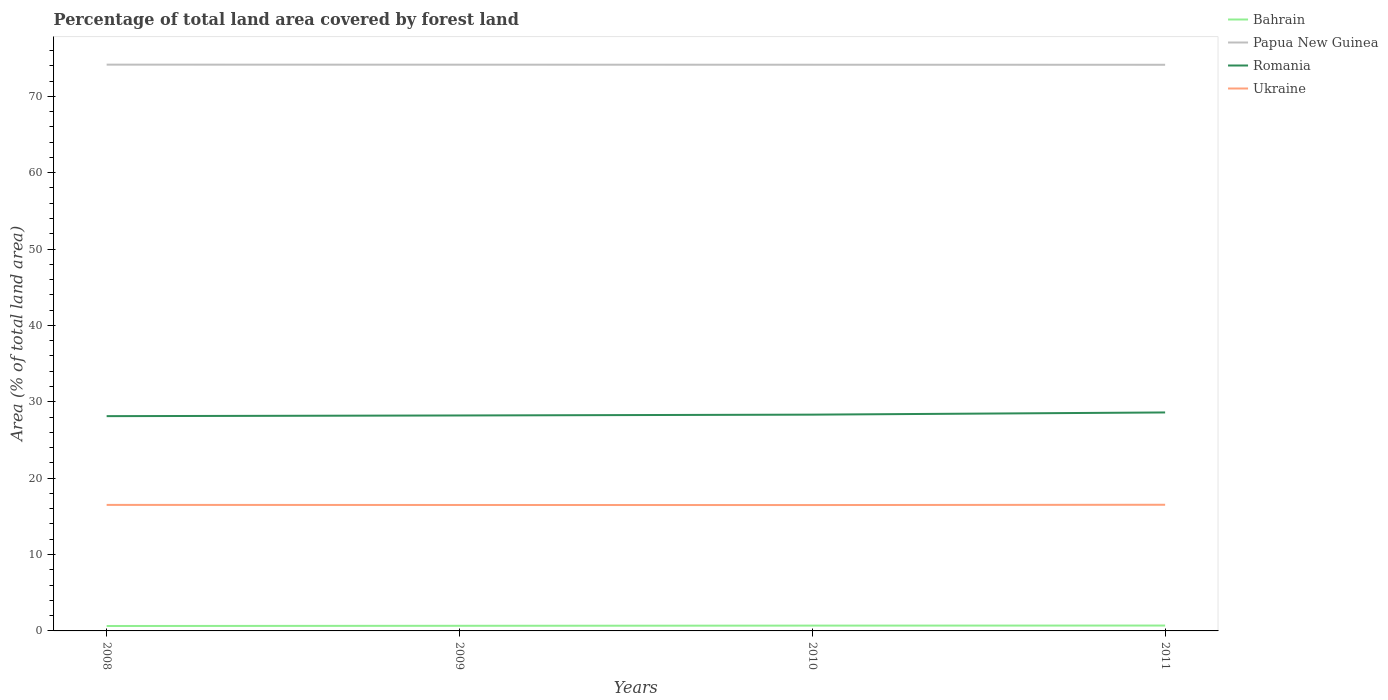Across all years, what is the maximum percentage of forest land in Papua New Guinea?
Provide a succinct answer. 74.13. In which year was the percentage of forest land in Romania maximum?
Offer a terse response. 2008. What is the total percentage of forest land in Papua New Guinea in the graph?
Provide a short and direct response. 0.01. What is the difference between the highest and the second highest percentage of forest land in Ukraine?
Offer a very short reply. 0.04. How many years are there in the graph?
Your answer should be compact. 4. What is the difference between two consecutive major ticks on the Y-axis?
Your response must be concise. 10. Are the values on the major ticks of Y-axis written in scientific E-notation?
Your answer should be compact. No. Does the graph contain any zero values?
Give a very brief answer. No. Does the graph contain grids?
Ensure brevity in your answer.  No. How many legend labels are there?
Offer a terse response. 4. What is the title of the graph?
Offer a terse response. Percentage of total land area covered by forest land. Does "Uzbekistan" appear as one of the legend labels in the graph?
Provide a succinct answer. No. What is the label or title of the Y-axis?
Your answer should be compact. Area (% of total land area). What is the Area (% of total land area) of Bahrain in 2008?
Your response must be concise. 0.64. What is the Area (% of total land area) of Papua New Guinea in 2008?
Your answer should be compact. 74.15. What is the Area (% of total land area) of Romania in 2008?
Your answer should be compact. 28.12. What is the Area (% of total land area) of Ukraine in 2008?
Your answer should be very brief. 16.5. What is the Area (% of total land area) of Bahrain in 2009?
Ensure brevity in your answer.  0.67. What is the Area (% of total land area) of Papua New Guinea in 2009?
Give a very brief answer. 74.14. What is the Area (% of total land area) of Romania in 2009?
Provide a short and direct response. 28.21. What is the Area (% of total land area) of Ukraine in 2009?
Your answer should be very brief. 16.49. What is the Area (% of total land area) of Bahrain in 2010?
Make the answer very short. 0.7. What is the Area (% of total land area) in Papua New Guinea in 2010?
Ensure brevity in your answer.  74.14. What is the Area (% of total land area) in Romania in 2010?
Offer a very short reply. 28.32. What is the Area (% of total land area) of Ukraine in 2010?
Provide a short and direct response. 16.48. What is the Area (% of total land area) of Bahrain in 2011?
Make the answer very short. 0.7. What is the Area (% of total land area) in Papua New Guinea in 2011?
Make the answer very short. 74.13. What is the Area (% of total land area) in Romania in 2011?
Provide a short and direct response. 28.61. What is the Area (% of total land area) of Ukraine in 2011?
Provide a succinct answer. 16.52. Across all years, what is the maximum Area (% of total land area) of Bahrain?
Offer a very short reply. 0.7. Across all years, what is the maximum Area (% of total land area) in Papua New Guinea?
Give a very brief answer. 74.15. Across all years, what is the maximum Area (% of total land area) in Romania?
Your response must be concise. 28.61. Across all years, what is the maximum Area (% of total land area) in Ukraine?
Keep it short and to the point. 16.52. Across all years, what is the minimum Area (% of total land area) of Bahrain?
Provide a short and direct response. 0.64. Across all years, what is the minimum Area (% of total land area) of Papua New Guinea?
Provide a succinct answer. 74.13. Across all years, what is the minimum Area (% of total land area) of Romania?
Keep it short and to the point. 28.12. Across all years, what is the minimum Area (% of total land area) of Ukraine?
Offer a terse response. 16.48. What is the total Area (% of total land area) in Bahrain in the graph?
Your answer should be very brief. 2.72. What is the total Area (% of total land area) of Papua New Guinea in the graph?
Offer a very short reply. 296.55. What is the total Area (% of total land area) in Romania in the graph?
Your response must be concise. 113.26. What is the total Area (% of total land area) of Ukraine in the graph?
Your answer should be compact. 65.99. What is the difference between the Area (% of total land area) in Bahrain in 2008 and that in 2009?
Offer a very short reply. -0.03. What is the difference between the Area (% of total land area) in Papua New Guinea in 2008 and that in 2009?
Offer a very short reply. 0.01. What is the difference between the Area (% of total land area) in Romania in 2008 and that in 2009?
Make the answer very short. -0.09. What is the difference between the Area (% of total land area) of Ukraine in 2008 and that in 2009?
Give a very brief answer. 0.01. What is the difference between the Area (% of total land area) in Bahrain in 2008 and that in 2010?
Your response must be concise. -0.05. What is the difference between the Area (% of total land area) in Papua New Guinea in 2008 and that in 2010?
Provide a short and direct response. 0.01. What is the difference between the Area (% of total land area) of Romania in 2008 and that in 2010?
Make the answer very short. -0.2. What is the difference between the Area (% of total land area) in Ukraine in 2008 and that in 2010?
Provide a short and direct response. 0.02. What is the difference between the Area (% of total land area) in Bahrain in 2008 and that in 2011?
Offer a terse response. -0.06. What is the difference between the Area (% of total land area) in Papua New Guinea in 2008 and that in 2011?
Ensure brevity in your answer.  0.02. What is the difference between the Area (% of total land area) in Romania in 2008 and that in 2011?
Offer a terse response. -0.48. What is the difference between the Area (% of total land area) of Ukraine in 2008 and that in 2011?
Give a very brief answer. -0.02. What is the difference between the Area (% of total land area) in Bahrain in 2009 and that in 2010?
Provide a short and direct response. -0.02. What is the difference between the Area (% of total land area) of Papua New Guinea in 2009 and that in 2010?
Your answer should be compact. 0.01. What is the difference between the Area (% of total land area) in Romania in 2009 and that in 2010?
Your answer should be very brief. -0.11. What is the difference between the Area (% of total land area) of Ukraine in 2009 and that in 2010?
Provide a succinct answer. 0.01. What is the difference between the Area (% of total land area) in Bahrain in 2009 and that in 2011?
Provide a succinct answer. -0.03. What is the difference between the Area (% of total land area) in Papua New Guinea in 2009 and that in 2011?
Your answer should be very brief. 0.01. What is the difference between the Area (% of total land area) in Romania in 2009 and that in 2011?
Offer a terse response. -0.39. What is the difference between the Area (% of total land area) in Ukraine in 2009 and that in 2011?
Offer a terse response. -0.03. What is the difference between the Area (% of total land area) in Bahrain in 2010 and that in 2011?
Make the answer very short. -0.01. What is the difference between the Area (% of total land area) of Papua New Guinea in 2010 and that in 2011?
Ensure brevity in your answer.  0.01. What is the difference between the Area (% of total land area) of Romania in 2010 and that in 2011?
Your response must be concise. -0.29. What is the difference between the Area (% of total land area) in Ukraine in 2010 and that in 2011?
Make the answer very short. -0.04. What is the difference between the Area (% of total land area) of Bahrain in 2008 and the Area (% of total land area) of Papua New Guinea in 2009?
Offer a very short reply. -73.5. What is the difference between the Area (% of total land area) of Bahrain in 2008 and the Area (% of total land area) of Romania in 2009?
Provide a succinct answer. -27.57. What is the difference between the Area (% of total land area) of Bahrain in 2008 and the Area (% of total land area) of Ukraine in 2009?
Ensure brevity in your answer.  -15.85. What is the difference between the Area (% of total land area) in Papua New Guinea in 2008 and the Area (% of total land area) in Romania in 2009?
Offer a very short reply. 45.94. What is the difference between the Area (% of total land area) in Papua New Guinea in 2008 and the Area (% of total land area) in Ukraine in 2009?
Ensure brevity in your answer.  57.66. What is the difference between the Area (% of total land area) of Romania in 2008 and the Area (% of total land area) of Ukraine in 2009?
Your answer should be very brief. 11.63. What is the difference between the Area (% of total land area) of Bahrain in 2008 and the Area (% of total land area) of Papua New Guinea in 2010?
Your answer should be very brief. -73.49. What is the difference between the Area (% of total land area) of Bahrain in 2008 and the Area (% of total land area) of Romania in 2010?
Ensure brevity in your answer.  -27.68. What is the difference between the Area (% of total land area) in Bahrain in 2008 and the Area (% of total land area) in Ukraine in 2010?
Make the answer very short. -15.84. What is the difference between the Area (% of total land area) in Papua New Guinea in 2008 and the Area (% of total land area) in Romania in 2010?
Ensure brevity in your answer.  45.83. What is the difference between the Area (% of total land area) in Papua New Guinea in 2008 and the Area (% of total land area) in Ukraine in 2010?
Your answer should be compact. 57.67. What is the difference between the Area (% of total land area) of Romania in 2008 and the Area (% of total land area) of Ukraine in 2010?
Provide a succinct answer. 11.64. What is the difference between the Area (% of total land area) in Bahrain in 2008 and the Area (% of total land area) in Papua New Guinea in 2011?
Offer a terse response. -73.48. What is the difference between the Area (% of total land area) of Bahrain in 2008 and the Area (% of total land area) of Romania in 2011?
Your answer should be very brief. -27.96. What is the difference between the Area (% of total land area) in Bahrain in 2008 and the Area (% of total land area) in Ukraine in 2011?
Your response must be concise. -15.87. What is the difference between the Area (% of total land area) of Papua New Guinea in 2008 and the Area (% of total land area) of Romania in 2011?
Provide a short and direct response. 45.54. What is the difference between the Area (% of total land area) of Papua New Guinea in 2008 and the Area (% of total land area) of Ukraine in 2011?
Offer a very short reply. 57.63. What is the difference between the Area (% of total land area) in Romania in 2008 and the Area (% of total land area) in Ukraine in 2011?
Make the answer very short. 11.6. What is the difference between the Area (% of total land area) in Bahrain in 2009 and the Area (% of total land area) in Papua New Guinea in 2010?
Your response must be concise. -73.46. What is the difference between the Area (% of total land area) in Bahrain in 2009 and the Area (% of total land area) in Romania in 2010?
Offer a very short reply. -27.65. What is the difference between the Area (% of total land area) in Bahrain in 2009 and the Area (% of total land area) in Ukraine in 2010?
Keep it short and to the point. -15.81. What is the difference between the Area (% of total land area) of Papua New Guinea in 2009 and the Area (% of total land area) of Romania in 2010?
Offer a very short reply. 45.82. What is the difference between the Area (% of total land area) in Papua New Guinea in 2009 and the Area (% of total land area) in Ukraine in 2010?
Offer a very short reply. 57.66. What is the difference between the Area (% of total land area) of Romania in 2009 and the Area (% of total land area) of Ukraine in 2010?
Give a very brief answer. 11.73. What is the difference between the Area (% of total land area) in Bahrain in 2009 and the Area (% of total land area) in Papua New Guinea in 2011?
Keep it short and to the point. -73.46. What is the difference between the Area (% of total land area) in Bahrain in 2009 and the Area (% of total land area) in Romania in 2011?
Give a very brief answer. -27.93. What is the difference between the Area (% of total land area) of Bahrain in 2009 and the Area (% of total land area) of Ukraine in 2011?
Provide a short and direct response. -15.85. What is the difference between the Area (% of total land area) of Papua New Guinea in 2009 and the Area (% of total land area) of Romania in 2011?
Your response must be concise. 45.54. What is the difference between the Area (% of total land area) of Papua New Guinea in 2009 and the Area (% of total land area) of Ukraine in 2011?
Provide a succinct answer. 57.62. What is the difference between the Area (% of total land area) of Romania in 2009 and the Area (% of total land area) of Ukraine in 2011?
Keep it short and to the point. 11.69. What is the difference between the Area (% of total land area) of Bahrain in 2010 and the Area (% of total land area) of Papua New Guinea in 2011?
Your answer should be very brief. -73.43. What is the difference between the Area (% of total land area) in Bahrain in 2010 and the Area (% of total land area) in Romania in 2011?
Your answer should be very brief. -27.91. What is the difference between the Area (% of total land area) of Bahrain in 2010 and the Area (% of total land area) of Ukraine in 2011?
Offer a very short reply. -15.82. What is the difference between the Area (% of total land area) of Papua New Guinea in 2010 and the Area (% of total land area) of Romania in 2011?
Your answer should be very brief. 45.53. What is the difference between the Area (% of total land area) of Papua New Guinea in 2010 and the Area (% of total land area) of Ukraine in 2011?
Keep it short and to the point. 57.62. What is the difference between the Area (% of total land area) in Romania in 2010 and the Area (% of total land area) in Ukraine in 2011?
Offer a very short reply. 11.8. What is the average Area (% of total land area) in Bahrain per year?
Provide a short and direct response. 0.68. What is the average Area (% of total land area) in Papua New Guinea per year?
Your answer should be compact. 74.14. What is the average Area (% of total land area) of Romania per year?
Make the answer very short. 28.31. What is the average Area (% of total land area) of Ukraine per year?
Your answer should be very brief. 16.5. In the year 2008, what is the difference between the Area (% of total land area) in Bahrain and Area (% of total land area) in Papua New Guinea?
Keep it short and to the point. -73.5. In the year 2008, what is the difference between the Area (% of total land area) in Bahrain and Area (% of total land area) in Romania?
Your response must be concise. -27.48. In the year 2008, what is the difference between the Area (% of total land area) of Bahrain and Area (% of total land area) of Ukraine?
Make the answer very short. -15.86. In the year 2008, what is the difference between the Area (% of total land area) in Papua New Guinea and Area (% of total land area) in Romania?
Give a very brief answer. 46.02. In the year 2008, what is the difference between the Area (% of total land area) of Papua New Guinea and Area (% of total land area) of Ukraine?
Your answer should be compact. 57.65. In the year 2008, what is the difference between the Area (% of total land area) in Romania and Area (% of total land area) in Ukraine?
Provide a succinct answer. 11.62. In the year 2009, what is the difference between the Area (% of total land area) in Bahrain and Area (% of total land area) in Papua New Guinea?
Provide a short and direct response. -73.47. In the year 2009, what is the difference between the Area (% of total land area) in Bahrain and Area (% of total land area) in Romania?
Keep it short and to the point. -27.54. In the year 2009, what is the difference between the Area (% of total land area) in Bahrain and Area (% of total land area) in Ukraine?
Give a very brief answer. -15.82. In the year 2009, what is the difference between the Area (% of total land area) in Papua New Guinea and Area (% of total land area) in Romania?
Keep it short and to the point. 45.93. In the year 2009, what is the difference between the Area (% of total land area) in Papua New Guinea and Area (% of total land area) in Ukraine?
Offer a terse response. 57.65. In the year 2009, what is the difference between the Area (% of total land area) in Romania and Area (% of total land area) in Ukraine?
Your answer should be compact. 11.72. In the year 2010, what is the difference between the Area (% of total land area) in Bahrain and Area (% of total land area) in Papua New Guinea?
Provide a succinct answer. -73.44. In the year 2010, what is the difference between the Area (% of total land area) in Bahrain and Area (% of total land area) in Romania?
Your response must be concise. -27.62. In the year 2010, what is the difference between the Area (% of total land area) in Bahrain and Area (% of total land area) in Ukraine?
Provide a succinct answer. -15.79. In the year 2010, what is the difference between the Area (% of total land area) in Papua New Guinea and Area (% of total land area) in Romania?
Offer a very short reply. 45.82. In the year 2010, what is the difference between the Area (% of total land area) of Papua New Guinea and Area (% of total land area) of Ukraine?
Your answer should be compact. 57.65. In the year 2010, what is the difference between the Area (% of total land area) in Romania and Area (% of total land area) in Ukraine?
Offer a terse response. 11.84. In the year 2011, what is the difference between the Area (% of total land area) of Bahrain and Area (% of total land area) of Papua New Guinea?
Provide a succinct answer. -73.43. In the year 2011, what is the difference between the Area (% of total land area) in Bahrain and Area (% of total land area) in Romania?
Offer a terse response. -27.9. In the year 2011, what is the difference between the Area (% of total land area) of Bahrain and Area (% of total land area) of Ukraine?
Your answer should be compact. -15.81. In the year 2011, what is the difference between the Area (% of total land area) of Papua New Guinea and Area (% of total land area) of Romania?
Provide a succinct answer. 45.52. In the year 2011, what is the difference between the Area (% of total land area) of Papua New Guinea and Area (% of total land area) of Ukraine?
Offer a terse response. 57.61. In the year 2011, what is the difference between the Area (% of total land area) of Romania and Area (% of total land area) of Ukraine?
Make the answer very short. 12.09. What is the ratio of the Area (% of total land area) in Bahrain in 2008 to that in 2009?
Give a very brief answer. 0.96. What is the ratio of the Area (% of total land area) in Romania in 2008 to that in 2009?
Give a very brief answer. 1. What is the ratio of the Area (% of total land area) in Bahrain in 2008 to that in 2010?
Provide a succinct answer. 0.93. What is the ratio of the Area (% of total land area) in Papua New Guinea in 2008 to that in 2010?
Your response must be concise. 1. What is the ratio of the Area (% of total land area) of Romania in 2008 to that in 2010?
Give a very brief answer. 0.99. What is the ratio of the Area (% of total land area) of Ukraine in 2008 to that in 2010?
Your answer should be very brief. 1. What is the ratio of the Area (% of total land area) of Bahrain in 2008 to that in 2011?
Provide a succinct answer. 0.92. What is the ratio of the Area (% of total land area) of Papua New Guinea in 2008 to that in 2011?
Provide a short and direct response. 1. What is the ratio of the Area (% of total land area) of Romania in 2008 to that in 2011?
Offer a terse response. 0.98. What is the ratio of the Area (% of total land area) in Bahrain in 2009 to that in 2010?
Your answer should be compact. 0.96. What is the ratio of the Area (% of total land area) in Papua New Guinea in 2009 to that in 2010?
Provide a succinct answer. 1. What is the ratio of the Area (% of total land area) in Romania in 2009 to that in 2010?
Provide a succinct answer. 1. What is the ratio of the Area (% of total land area) in Ukraine in 2009 to that in 2010?
Keep it short and to the point. 1. What is the ratio of the Area (% of total land area) in Bahrain in 2009 to that in 2011?
Provide a short and direct response. 0.95. What is the ratio of the Area (% of total land area) of Romania in 2009 to that in 2011?
Make the answer very short. 0.99. What is the ratio of the Area (% of total land area) in Ukraine in 2009 to that in 2011?
Your answer should be compact. 1. What is the ratio of the Area (% of total land area) of Bahrain in 2010 to that in 2011?
Offer a terse response. 0.99. What is the ratio of the Area (% of total land area) in Romania in 2010 to that in 2011?
Provide a succinct answer. 0.99. What is the difference between the highest and the second highest Area (% of total land area) in Bahrain?
Provide a succinct answer. 0.01. What is the difference between the highest and the second highest Area (% of total land area) in Papua New Guinea?
Ensure brevity in your answer.  0.01. What is the difference between the highest and the second highest Area (% of total land area) of Romania?
Provide a short and direct response. 0.29. What is the difference between the highest and the second highest Area (% of total land area) in Ukraine?
Ensure brevity in your answer.  0.02. What is the difference between the highest and the lowest Area (% of total land area) in Bahrain?
Your answer should be compact. 0.06. What is the difference between the highest and the lowest Area (% of total land area) in Papua New Guinea?
Give a very brief answer. 0.02. What is the difference between the highest and the lowest Area (% of total land area) of Romania?
Give a very brief answer. 0.48. What is the difference between the highest and the lowest Area (% of total land area) of Ukraine?
Give a very brief answer. 0.04. 